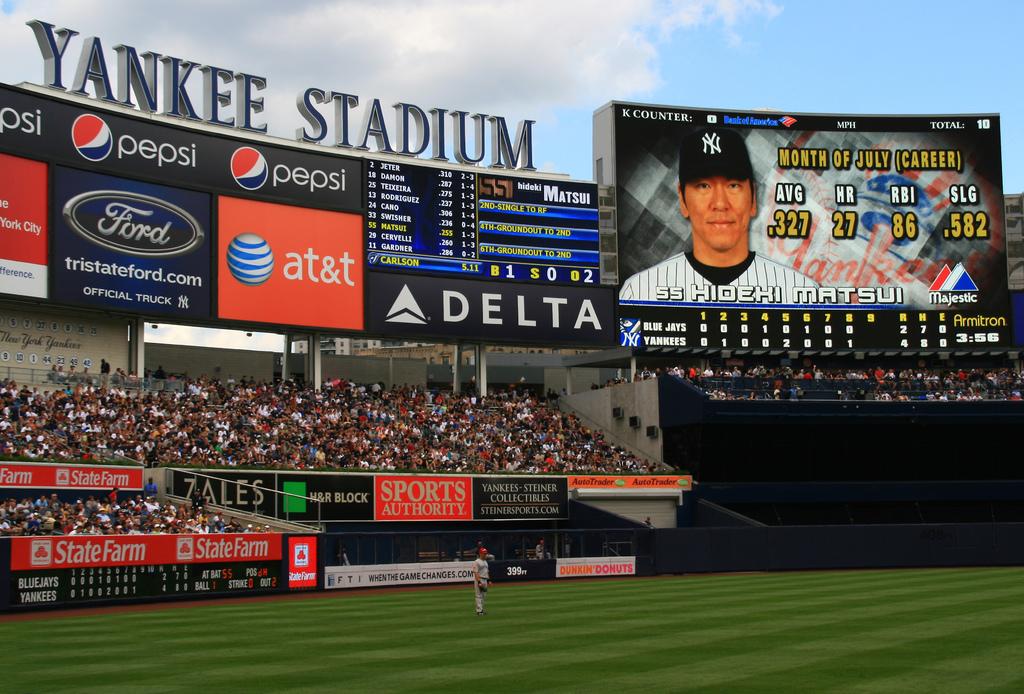Who is up to bat?
Ensure brevity in your answer.  Hideki matsui. 